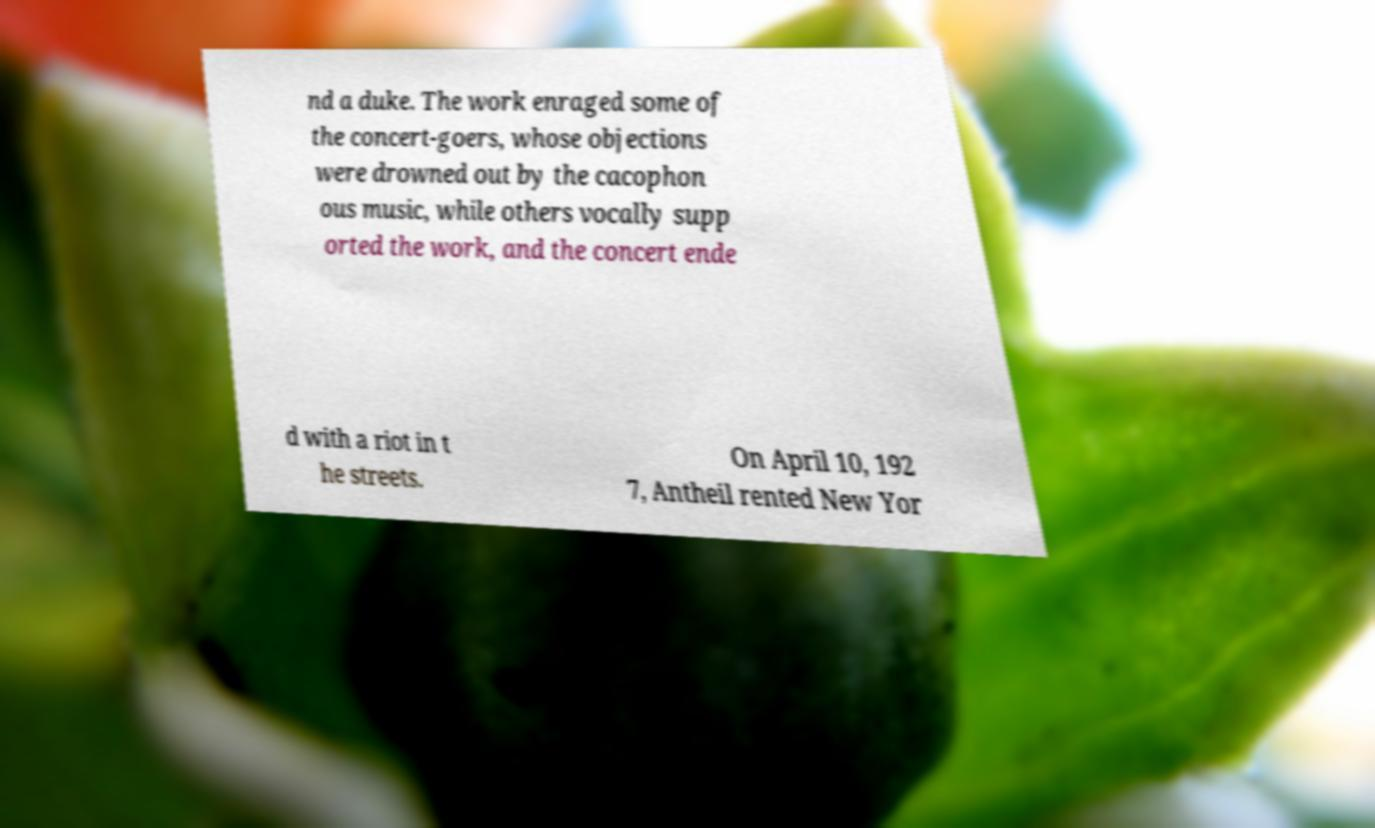Can you read and provide the text displayed in the image?This photo seems to have some interesting text. Can you extract and type it out for me? nd a duke. The work enraged some of the concert-goers, whose objections were drowned out by the cacophon ous music, while others vocally supp orted the work, and the concert ende d with a riot in t he streets. On April 10, 192 7, Antheil rented New Yor 